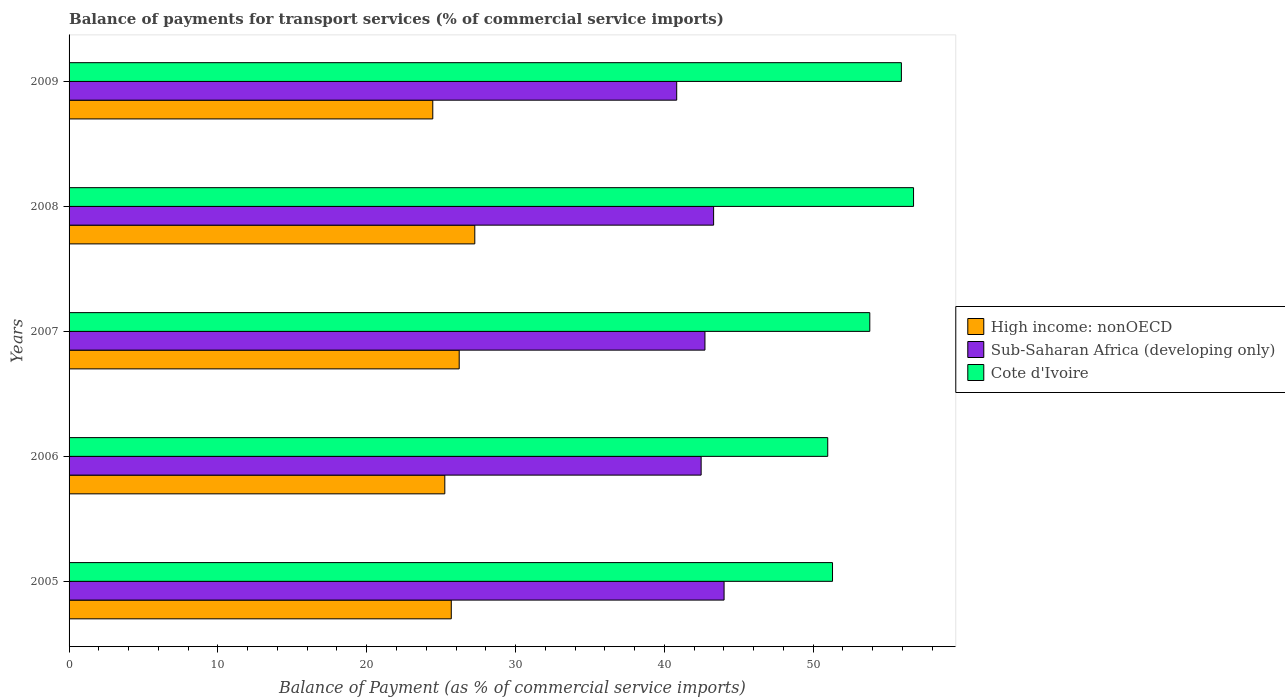Are the number of bars on each tick of the Y-axis equal?
Offer a terse response. Yes. How many bars are there on the 5th tick from the top?
Provide a succinct answer. 3. How many bars are there on the 1st tick from the bottom?
Provide a short and direct response. 3. What is the label of the 2nd group of bars from the top?
Your answer should be very brief. 2008. In how many cases, is the number of bars for a given year not equal to the number of legend labels?
Provide a short and direct response. 0. What is the balance of payments for transport services in High income: nonOECD in 2007?
Give a very brief answer. 26.21. Across all years, what is the maximum balance of payments for transport services in Sub-Saharan Africa (developing only)?
Provide a succinct answer. 44.01. Across all years, what is the minimum balance of payments for transport services in Sub-Saharan Africa (developing only)?
Your response must be concise. 40.83. In which year was the balance of payments for transport services in High income: nonOECD minimum?
Make the answer very short. 2009. What is the total balance of payments for transport services in Cote d'Ivoire in the graph?
Your answer should be very brief. 268.74. What is the difference between the balance of payments for transport services in High income: nonOECD in 2005 and that in 2007?
Provide a short and direct response. -0.53. What is the difference between the balance of payments for transport services in Sub-Saharan Africa (developing only) in 2005 and the balance of payments for transport services in High income: nonOECD in 2008?
Offer a very short reply. 16.75. What is the average balance of payments for transport services in High income: nonOECD per year?
Your response must be concise. 25.77. In the year 2008, what is the difference between the balance of payments for transport services in Sub-Saharan Africa (developing only) and balance of payments for transport services in Cote d'Ivoire?
Give a very brief answer. -13.43. In how many years, is the balance of payments for transport services in High income: nonOECD greater than 30 %?
Provide a short and direct response. 0. What is the ratio of the balance of payments for transport services in Cote d'Ivoire in 2006 to that in 2008?
Make the answer very short. 0.9. What is the difference between the highest and the second highest balance of payments for transport services in High income: nonOECD?
Keep it short and to the point. 1.05. What is the difference between the highest and the lowest balance of payments for transport services in Sub-Saharan Africa (developing only)?
Offer a very short reply. 3.18. In how many years, is the balance of payments for transport services in High income: nonOECD greater than the average balance of payments for transport services in High income: nonOECD taken over all years?
Offer a terse response. 2. What does the 2nd bar from the top in 2009 represents?
Your response must be concise. Sub-Saharan Africa (developing only). What does the 2nd bar from the bottom in 2009 represents?
Your answer should be very brief. Sub-Saharan Africa (developing only). Are the values on the major ticks of X-axis written in scientific E-notation?
Offer a terse response. No. Does the graph contain any zero values?
Make the answer very short. No. How many legend labels are there?
Make the answer very short. 3. How are the legend labels stacked?
Your answer should be compact. Vertical. What is the title of the graph?
Your answer should be very brief. Balance of payments for transport services (% of commercial service imports). What is the label or title of the X-axis?
Keep it short and to the point. Balance of Payment (as % of commercial service imports). What is the label or title of the Y-axis?
Your answer should be compact. Years. What is the Balance of Payment (as % of commercial service imports) in High income: nonOECD in 2005?
Provide a succinct answer. 25.68. What is the Balance of Payment (as % of commercial service imports) in Sub-Saharan Africa (developing only) in 2005?
Keep it short and to the point. 44.01. What is the Balance of Payment (as % of commercial service imports) of Cote d'Ivoire in 2005?
Your answer should be compact. 51.3. What is the Balance of Payment (as % of commercial service imports) in High income: nonOECD in 2006?
Offer a very short reply. 25.25. What is the Balance of Payment (as % of commercial service imports) in Sub-Saharan Africa (developing only) in 2006?
Your answer should be very brief. 42.47. What is the Balance of Payment (as % of commercial service imports) of Cote d'Ivoire in 2006?
Provide a succinct answer. 50.98. What is the Balance of Payment (as % of commercial service imports) in High income: nonOECD in 2007?
Ensure brevity in your answer.  26.21. What is the Balance of Payment (as % of commercial service imports) of Sub-Saharan Africa (developing only) in 2007?
Offer a terse response. 42.73. What is the Balance of Payment (as % of commercial service imports) in Cote d'Ivoire in 2007?
Ensure brevity in your answer.  53.8. What is the Balance of Payment (as % of commercial service imports) of High income: nonOECD in 2008?
Give a very brief answer. 27.26. What is the Balance of Payment (as % of commercial service imports) of Sub-Saharan Africa (developing only) in 2008?
Keep it short and to the point. 43.31. What is the Balance of Payment (as % of commercial service imports) of Cote d'Ivoire in 2008?
Give a very brief answer. 56.74. What is the Balance of Payment (as % of commercial service imports) in High income: nonOECD in 2009?
Provide a succinct answer. 24.44. What is the Balance of Payment (as % of commercial service imports) in Sub-Saharan Africa (developing only) in 2009?
Make the answer very short. 40.83. What is the Balance of Payment (as % of commercial service imports) in Cote d'Ivoire in 2009?
Provide a short and direct response. 55.92. Across all years, what is the maximum Balance of Payment (as % of commercial service imports) in High income: nonOECD?
Ensure brevity in your answer.  27.26. Across all years, what is the maximum Balance of Payment (as % of commercial service imports) of Sub-Saharan Africa (developing only)?
Your response must be concise. 44.01. Across all years, what is the maximum Balance of Payment (as % of commercial service imports) of Cote d'Ivoire?
Your answer should be very brief. 56.74. Across all years, what is the minimum Balance of Payment (as % of commercial service imports) in High income: nonOECD?
Offer a very short reply. 24.44. Across all years, what is the minimum Balance of Payment (as % of commercial service imports) in Sub-Saharan Africa (developing only)?
Your response must be concise. 40.83. Across all years, what is the minimum Balance of Payment (as % of commercial service imports) in Cote d'Ivoire?
Keep it short and to the point. 50.98. What is the total Balance of Payment (as % of commercial service imports) of High income: nonOECD in the graph?
Give a very brief answer. 128.84. What is the total Balance of Payment (as % of commercial service imports) in Sub-Saharan Africa (developing only) in the graph?
Ensure brevity in your answer.  213.34. What is the total Balance of Payment (as % of commercial service imports) of Cote d'Ivoire in the graph?
Your answer should be compact. 268.74. What is the difference between the Balance of Payment (as % of commercial service imports) of High income: nonOECD in 2005 and that in 2006?
Offer a very short reply. 0.43. What is the difference between the Balance of Payment (as % of commercial service imports) in Sub-Saharan Africa (developing only) in 2005 and that in 2006?
Provide a succinct answer. 1.54. What is the difference between the Balance of Payment (as % of commercial service imports) of Cote d'Ivoire in 2005 and that in 2006?
Keep it short and to the point. 0.32. What is the difference between the Balance of Payment (as % of commercial service imports) of High income: nonOECD in 2005 and that in 2007?
Your answer should be very brief. -0.53. What is the difference between the Balance of Payment (as % of commercial service imports) in Sub-Saharan Africa (developing only) in 2005 and that in 2007?
Make the answer very short. 1.28. What is the difference between the Balance of Payment (as % of commercial service imports) of Cote d'Ivoire in 2005 and that in 2007?
Provide a short and direct response. -2.5. What is the difference between the Balance of Payment (as % of commercial service imports) in High income: nonOECD in 2005 and that in 2008?
Your response must be concise. -1.58. What is the difference between the Balance of Payment (as % of commercial service imports) in Sub-Saharan Africa (developing only) in 2005 and that in 2008?
Your response must be concise. 0.7. What is the difference between the Balance of Payment (as % of commercial service imports) of Cote d'Ivoire in 2005 and that in 2008?
Your answer should be compact. -5.45. What is the difference between the Balance of Payment (as % of commercial service imports) of High income: nonOECD in 2005 and that in 2009?
Ensure brevity in your answer.  1.24. What is the difference between the Balance of Payment (as % of commercial service imports) of Sub-Saharan Africa (developing only) in 2005 and that in 2009?
Your response must be concise. 3.18. What is the difference between the Balance of Payment (as % of commercial service imports) in Cote d'Ivoire in 2005 and that in 2009?
Offer a terse response. -4.63. What is the difference between the Balance of Payment (as % of commercial service imports) of High income: nonOECD in 2006 and that in 2007?
Give a very brief answer. -0.97. What is the difference between the Balance of Payment (as % of commercial service imports) of Sub-Saharan Africa (developing only) in 2006 and that in 2007?
Provide a short and direct response. -0.26. What is the difference between the Balance of Payment (as % of commercial service imports) of Cote d'Ivoire in 2006 and that in 2007?
Ensure brevity in your answer.  -2.83. What is the difference between the Balance of Payment (as % of commercial service imports) of High income: nonOECD in 2006 and that in 2008?
Provide a short and direct response. -2.01. What is the difference between the Balance of Payment (as % of commercial service imports) in Sub-Saharan Africa (developing only) in 2006 and that in 2008?
Offer a terse response. -0.84. What is the difference between the Balance of Payment (as % of commercial service imports) of Cote d'Ivoire in 2006 and that in 2008?
Provide a succinct answer. -5.77. What is the difference between the Balance of Payment (as % of commercial service imports) in High income: nonOECD in 2006 and that in 2009?
Offer a terse response. 0.81. What is the difference between the Balance of Payment (as % of commercial service imports) of Sub-Saharan Africa (developing only) in 2006 and that in 2009?
Keep it short and to the point. 1.64. What is the difference between the Balance of Payment (as % of commercial service imports) in Cote d'Ivoire in 2006 and that in 2009?
Make the answer very short. -4.95. What is the difference between the Balance of Payment (as % of commercial service imports) in High income: nonOECD in 2007 and that in 2008?
Offer a very short reply. -1.05. What is the difference between the Balance of Payment (as % of commercial service imports) in Sub-Saharan Africa (developing only) in 2007 and that in 2008?
Offer a very short reply. -0.58. What is the difference between the Balance of Payment (as % of commercial service imports) in Cote d'Ivoire in 2007 and that in 2008?
Provide a succinct answer. -2.94. What is the difference between the Balance of Payment (as % of commercial service imports) of High income: nonOECD in 2007 and that in 2009?
Your response must be concise. 1.78. What is the difference between the Balance of Payment (as % of commercial service imports) in Sub-Saharan Africa (developing only) in 2007 and that in 2009?
Your answer should be compact. 1.9. What is the difference between the Balance of Payment (as % of commercial service imports) of Cote d'Ivoire in 2007 and that in 2009?
Offer a very short reply. -2.12. What is the difference between the Balance of Payment (as % of commercial service imports) of High income: nonOECD in 2008 and that in 2009?
Offer a very short reply. 2.82. What is the difference between the Balance of Payment (as % of commercial service imports) in Sub-Saharan Africa (developing only) in 2008 and that in 2009?
Give a very brief answer. 2.48. What is the difference between the Balance of Payment (as % of commercial service imports) of Cote d'Ivoire in 2008 and that in 2009?
Provide a succinct answer. 0.82. What is the difference between the Balance of Payment (as % of commercial service imports) of High income: nonOECD in 2005 and the Balance of Payment (as % of commercial service imports) of Sub-Saharan Africa (developing only) in 2006?
Provide a short and direct response. -16.79. What is the difference between the Balance of Payment (as % of commercial service imports) of High income: nonOECD in 2005 and the Balance of Payment (as % of commercial service imports) of Cote d'Ivoire in 2006?
Your answer should be compact. -25.29. What is the difference between the Balance of Payment (as % of commercial service imports) of Sub-Saharan Africa (developing only) in 2005 and the Balance of Payment (as % of commercial service imports) of Cote d'Ivoire in 2006?
Provide a short and direct response. -6.96. What is the difference between the Balance of Payment (as % of commercial service imports) of High income: nonOECD in 2005 and the Balance of Payment (as % of commercial service imports) of Sub-Saharan Africa (developing only) in 2007?
Provide a succinct answer. -17.05. What is the difference between the Balance of Payment (as % of commercial service imports) of High income: nonOECD in 2005 and the Balance of Payment (as % of commercial service imports) of Cote d'Ivoire in 2007?
Offer a very short reply. -28.12. What is the difference between the Balance of Payment (as % of commercial service imports) of Sub-Saharan Africa (developing only) in 2005 and the Balance of Payment (as % of commercial service imports) of Cote d'Ivoire in 2007?
Offer a terse response. -9.79. What is the difference between the Balance of Payment (as % of commercial service imports) in High income: nonOECD in 2005 and the Balance of Payment (as % of commercial service imports) in Sub-Saharan Africa (developing only) in 2008?
Your answer should be very brief. -17.63. What is the difference between the Balance of Payment (as % of commercial service imports) in High income: nonOECD in 2005 and the Balance of Payment (as % of commercial service imports) in Cote d'Ivoire in 2008?
Ensure brevity in your answer.  -31.06. What is the difference between the Balance of Payment (as % of commercial service imports) of Sub-Saharan Africa (developing only) in 2005 and the Balance of Payment (as % of commercial service imports) of Cote d'Ivoire in 2008?
Give a very brief answer. -12.73. What is the difference between the Balance of Payment (as % of commercial service imports) of High income: nonOECD in 2005 and the Balance of Payment (as % of commercial service imports) of Sub-Saharan Africa (developing only) in 2009?
Provide a succinct answer. -15.15. What is the difference between the Balance of Payment (as % of commercial service imports) in High income: nonOECD in 2005 and the Balance of Payment (as % of commercial service imports) in Cote d'Ivoire in 2009?
Ensure brevity in your answer.  -30.24. What is the difference between the Balance of Payment (as % of commercial service imports) of Sub-Saharan Africa (developing only) in 2005 and the Balance of Payment (as % of commercial service imports) of Cote d'Ivoire in 2009?
Provide a short and direct response. -11.91. What is the difference between the Balance of Payment (as % of commercial service imports) in High income: nonOECD in 2006 and the Balance of Payment (as % of commercial service imports) in Sub-Saharan Africa (developing only) in 2007?
Provide a succinct answer. -17.48. What is the difference between the Balance of Payment (as % of commercial service imports) in High income: nonOECD in 2006 and the Balance of Payment (as % of commercial service imports) in Cote d'Ivoire in 2007?
Ensure brevity in your answer.  -28.56. What is the difference between the Balance of Payment (as % of commercial service imports) in Sub-Saharan Africa (developing only) in 2006 and the Balance of Payment (as % of commercial service imports) in Cote d'Ivoire in 2007?
Give a very brief answer. -11.33. What is the difference between the Balance of Payment (as % of commercial service imports) of High income: nonOECD in 2006 and the Balance of Payment (as % of commercial service imports) of Sub-Saharan Africa (developing only) in 2008?
Ensure brevity in your answer.  -18.06. What is the difference between the Balance of Payment (as % of commercial service imports) of High income: nonOECD in 2006 and the Balance of Payment (as % of commercial service imports) of Cote d'Ivoire in 2008?
Your answer should be compact. -31.5. What is the difference between the Balance of Payment (as % of commercial service imports) in Sub-Saharan Africa (developing only) in 2006 and the Balance of Payment (as % of commercial service imports) in Cote d'Ivoire in 2008?
Give a very brief answer. -14.27. What is the difference between the Balance of Payment (as % of commercial service imports) in High income: nonOECD in 2006 and the Balance of Payment (as % of commercial service imports) in Sub-Saharan Africa (developing only) in 2009?
Offer a terse response. -15.58. What is the difference between the Balance of Payment (as % of commercial service imports) in High income: nonOECD in 2006 and the Balance of Payment (as % of commercial service imports) in Cote d'Ivoire in 2009?
Provide a short and direct response. -30.68. What is the difference between the Balance of Payment (as % of commercial service imports) in Sub-Saharan Africa (developing only) in 2006 and the Balance of Payment (as % of commercial service imports) in Cote d'Ivoire in 2009?
Give a very brief answer. -13.45. What is the difference between the Balance of Payment (as % of commercial service imports) of High income: nonOECD in 2007 and the Balance of Payment (as % of commercial service imports) of Sub-Saharan Africa (developing only) in 2008?
Ensure brevity in your answer.  -17.09. What is the difference between the Balance of Payment (as % of commercial service imports) in High income: nonOECD in 2007 and the Balance of Payment (as % of commercial service imports) in Cote d'Ivoire in 2008?
Give a very brief answer. -30.53. What is the difference between the Balance of Payment (as % of commercial service imports) in Sub-Saharan Africa (developing only) in 2007 and the Balance of Payment (as % of commercial service imports) in Cote d'Ivoire in 2008?
Your answer should be compact. -14.02. What is the difference between the Balance of Payment (as % of commercial service imports) of High income: nonOECD in 2007 and the Balance of Payment (as % of commercial service imports) of Sub-Saharan Africa (developing only) in 2009?
Offer a terse response. -14.61. What is the difference between the Balance of Payment (as % of commercial service imports) in High income: nonOECD in 2007 and the Balance of Payment (as % of commercial service imports) in Cote d'Ivoire in 2009?
Provide a short and direct response. -29.71. What is the difference between the Balance of Payment (as % of commercial service imports) in Sub-Saharan Africa (developing only) in 2007 and the Balance of Payment (as % of commercial service imports) in Cote d'Ivoire in 2009?
Give a very brief answer. -13.2. What is the difference between the Balance of Payment (as % of commercial service imports) in High income: nonOECD in 2008 and the Balance of Payment (as % of commercial service imports) in Sub-Saharan Africa (developing only) in 2009?
Make the answer very short. -13.57. What is the difference between the Balance of Payment (as % of commercial service imports) of High income: nonOECD in 2008 and the Balance of Payment (as % of commercial service imports) of Cote d'Ivoire in 2009?
Offer a very short reply. -28.66. What is the difference between the Balance of Payment (as % of commercial service imports) in Sub-Saharan Africa (developing only) in 2008 and the Balance of Payment (as % of commercial service imports) in Cote d'Ivoire in 2009?
Your answer should be compact. -12.62. What is the average Balance of Payment (as % of commercial service imports) of High income: nonOECD per year?
Make the answer very short. 25.77. What is the average Balance of Payment (as % of commercial service imports) in Sub-Saharan Africa (developing only) per year?
Offer a very short reply. 42.67. What is the average Balance of Payment (as % of commercial service imports) of Cote d'Ivoire per year?
Provide a succinct answer. 53.75. In the year 2005, what is the difference between the Balance of Payment (as % of commercial service imports) of High income: nonOECD and Balance of Payment (as % of commercial service imports) of Sub-Saharan Africa (developing only)?
Offer a very short reply. -18.33. In the year 2005, what is the difference between the Balance of Payment (as % of commercial service imports) in High income: nonOECD and Balance of Payment (as % of commercial service imports) in Cote d'Ivoire?
Your answer should be very brief. -25.62. In the year 2005, what is the difference between the Balance of Payment (as % of commercial service imports) of Sub-Saharan Africa (developing only) and Balance of Payment (as % of commercial service imports) of Cote d'Ivoire?
Give a very brief answer. -7.29. In the year 2006, what is the difference between the Balance of Payment (as % of commercial service imports) in High income: nonOECD and Balance of Payment (as % of commercial service imports) in Sub-Saharan Africa (developing only)?
Offer a very short reply. -17.22. In the year 2006, what is the difference between the Balance of Payment (as % of commercial service imports) in High income: nonOECD and Balance of Payment (as % of commercial service imports) in Cote d'Ivoire?
Ensure brevity in your answer.  -25.73. In the year 2006, what is the difference between the Balance of Payment (as % of commercial service imports) of Sub-Saharan Africa (developing only) and Balance of Payment (as % of commercial service imports) of Cote d'Ivoire?
Make the answer very short. -8.51. In the year 2007, what is the difference between the Balance of Payment (as % of commercial service imports) of High income: nonOECD and Balance of Payment (as % of commercial service imports) of Sub-Saharan Africa (developing only)?
Keep it short and to the point. -16.51. In the year 2007, what is the difference between the Balance of Payment (as % of commercial service imports) of High income: nonOECD and Balance of Payment (as % of commercial service imports) of Cote d'Ivoire?
Ensure brevity in your answer.  -27.59. In the year 2007, what is the difference between the Balance of Payment (as % of commercial service imports) in Sub-Saharan Africa (developing only) and Balance of Payment (as % of commercial service imports) in Cote d'Ivoire?
Make the answer very short. -11.08. In the year 2008, what is the difference between the Balance of Payment (as % of commercial service imports) of High income: nonOECD and Balance of Payment (as % of commercial service imports) of Sub-Saharan Africa (developing only)?
Give a very brief answer. -16.05. In the year 2008, what is the difference between the Balance of Payment (as % of commercial service imports) of High income: nonOECD and Balance of Payment (as % of commercial service imports) of Cote d'Ivoire?
Ensure brevity in your answer.  -29.48. In the year 2008, what is the difference between the Balance of Payment (as % of commercial service imports) in Sub-Saharan Africa (developing only) and Balance of Payment (as % of commercial service imports) in Cote d'Ivoire?
Provide a succinct answer. -13.43. In the year 2009, what is the difference between the Balance of Payment (as % of commercial service imports) in High income: nonOECD and Balance of Payment (as % of commercial service imports) in Sub-Saharan Africa (developing only)?
Your response must be concise. -16.39. In the year 2009, what is the difference between the Balance of Payment (as % of commercial service imports) in High income: nonOECD and Balance of Payment (as % of commercial service imports) in Cote d'Ivoire?
Offer a terse response. -31.49. In the year 2009, what is the difference between the Balance of Payment (as % of commercial service imports) in Sub-Saharan Africa (developing only) and Balance of Payment (as % of commercial service imports) in Cote d'Ivoire?
Your answer should be very brief. -15.1. What is the ratio of the Balance of Payment (as % of commercial service imports) in High income: nonOECD in 2005 to that in 2006?
Provide a succinct answer. 1.02. What is the ratio of the Balance of Payment (as % of commercial service imports) in Sub-Saharan Africa (developing only) in 2005 to that in 2006?
Your answer should be very brief. 1.04. What is the ratio of the Balance of Payment (as % of commercial service imports) of High income: nonOECD in 2005 to that in 2007?
Your response must be concise. 0.98. What is the ratio of the Balance of Payment (as % of commercial service imports) in Sub-Saharan Africa (developing only) in 2005 to that in 2007?
Your answer should be very brief. 1.03. What is the ratio of the Balance of Payment (as % of commercial service imports) of Cote d'Ivoire in 2005 to that in 2007?
Your answer should be compact. 0.95. What is the ratio of the Balance of Payment (as % of commercial service imports) of High income: nonOECD in 2005 to that in 2008?
Give a very brief answer. 0.94. What is the ratio of the Balance of Payment (as % of commercial service imports) of Sub-Saharan Africa (developing only) in 2005 to that in 2008?
Your answer should be very brief. 1.02. What is the ratio of the Balance of Payment (as % of commercial service imports) in Cote d'Ivoire in 2005 to that in 2008?
Offer a very short reply. 0.9. What is the ratio of the Balance of Payment (as % of commercial service imports) of High income: nonOECD in 2005 to that in 2009?
Provide a succinct answer. 1.05. What is the ratio of the Balance of Payment (as % of commercial service imports) of Sub-Saharan Africa (developing only) in 2005 to that in 2009?
Your answer should be very brief. 1.08. What is the ratio of the Balance of Payment (as % of commercial service imports) in Cote d'Ivoire in 2005 to that in 2009?
Ensure brevity in your answer.  0.92. What is the ratio of the Balance of Payment (as % of commercial service imports) in High income: nonOECD in 2006 to that in 2007?
Provide a succinct answer. 0.96. What is the ratio of the Balance of Payment (as % of commercial service imports) in Sub-Saharan Africa (developing only) in 2006 to that in 2007?
Your response must be concise. 0.99. What is the ratio of the Balance of Payment (as % of commercial service imports) of Cote d'Ivoire in 2006 to that in 2007?
Ensure brevity in your answer.  0.95. What is the ratio of the Balance of Payment (as % of commercial service imports) in High income: nonOECD in 2006 to that in 2008?
Give a very brief answer. 0.93. What is the ratio of the Balance of Payment (as % of commercial service imports) of Sub-Saharan Africa (developing only) in 2006 to that in 2008?
Your answer should be compact. 0.98. What is the ratio of the Balance of Payment (as % of commercial service imports) in Cote d'Ivoire in 2006 to that in 2008?
Ensure brevity in your answer.  0.9. What is the ratio of the Balance of Payment (as % of commercial service imports) in High income: nonOECD in 2006 to that in 2009?
Give a very brief answer. 1.03. What is the ratio of the Balance of Payment (as % of commercial service imports) of Sub-Saharan Africa (developing only) in 2006 to that in 2009?
Your response must be concise. 1.04. What is the ratio of the Balance of Payment (as % of commercial service imports) in Cote d'Ivoire in 2006 to that in 2009?
Ensure brevity in your answer.  0.91. What is the ratio of the Balance of Payment (as % of commercial service imports) in High income: nonOECD in 2007 to that in 2008?
Give a very brief answer. 0.96. What is the ratio of the Balance of Payment (as % of commercial service imports) in Sub-Saharan Africa (developing only) in 2007 to that in 2008?
Ensure brevity in your answer.  0.99. What is the ratio of the Balance of Payment (as % of commercial service imports) of Cote d'Ivoire in 2007 to that in 2008?
Give a very brief answer. 0.95. What is the ratio of the Balance of Payment (as % of commercial service imports) of High income: nonOECD in 2007 to that in 2009?
Provide a short and direct response. 1.07. What is the ratio of the Balance of Payment (as % of commercial service imports) of Sub-Saharan Africa (developing only) in 2007 to that in 2009?
Offer a very short reply. 1.05. What is the ratio of the Balance of Payment (as % of commercial service imports) in High income: nonOECD in 2008 to that in 2009?
Your response must be concise. 1.12. What is the ratio of the Balance of Payment (as % of commercial service imports) of Sub-Saharan Africa (developing only) in 2008 to that in 2009?
Offer a very short reply. 1.06. What is the ratio of the Balance of Payment (as % of commercial service imports) of Cote d'Ivoire in 2008 to that in 2009?
Offer a very short reply. 1.01. What is the difference between the highest and the second highest Balance of Payment (as % of commercial service imports) of High income: nonOECD?
Offer a very short reply. 1.05. What is the difference between the highest and the second highest Balance of Payment (as % of commercial service imports) in Sub-Saharan Africa (developing only)?
Keep it short and to the point. 0.7. What is the difference between the highest and the second highest Balance of Payment (as % of commercial service imports) of Cote d'Ivoire?
Provide a short and direct response. 0.82. What is the difference between the highest and the lowest Balance of Payment (as % of commercial service imports) in High income: nonOECD?
Provide a succinct answer. 2.82. What is the difference between the highest and the lowest Balance of Payment (as % of commercial service imports) in Sub-Saharan Africa (developing only)?
Give a very brief answer. 3.18. What is the difference between the highest and the lowest Balance of Payment (as % of commercial service imports) in Cote d'Ivoire?
Provide a short and direct response. 5.77. 